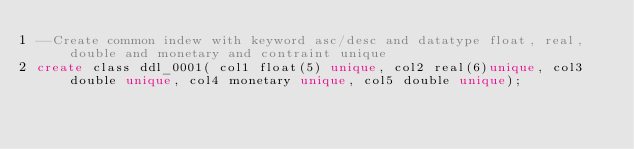Convert code to text. <code><loc_0><loc_0><loc_500><loc_500><_SQL_>--Create common indew with keyword asc/desc and datatype float, real, double and monetary and contraint unique
create class ddl_0001( col1 float(5) unique, col2 real(6)unique, col3 double unique, col4 monetary unique, col5 double unique);</code> 